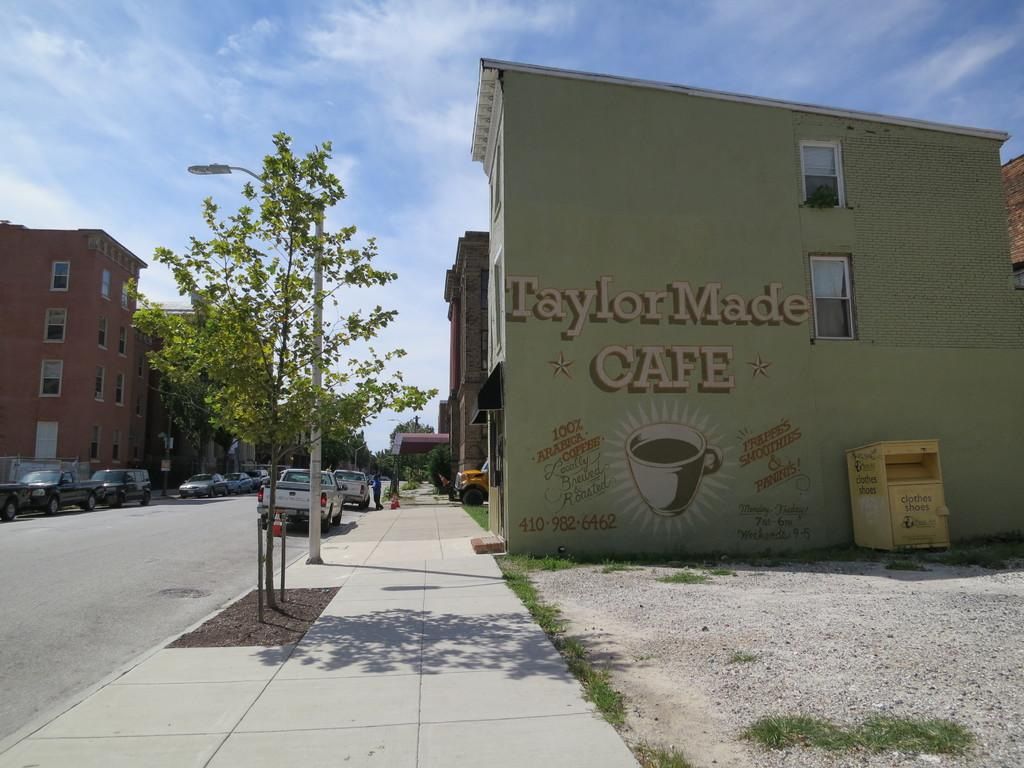What type of structures can be seen in the image? There are buildings in the image. What other natural elements are present in the image? There are trees in the image. What mode of transportation can be seen on the road in the image? Cars are visible on the road in the image. Can you describe the person in the image? There is a person in the image. What object is located on the right side of the image? There is a bin on the right side of the image. What vertical structure is present in the image? There is a pole in the image. What can be seen in the background of the image? The sky is visible in the background of the image. What type of collar can be seen on the person in the image? There is no collar visible on the person in the image. What taste is associated with the buildings in the image? Buildings do not have a taste; they are inanimate structures. 